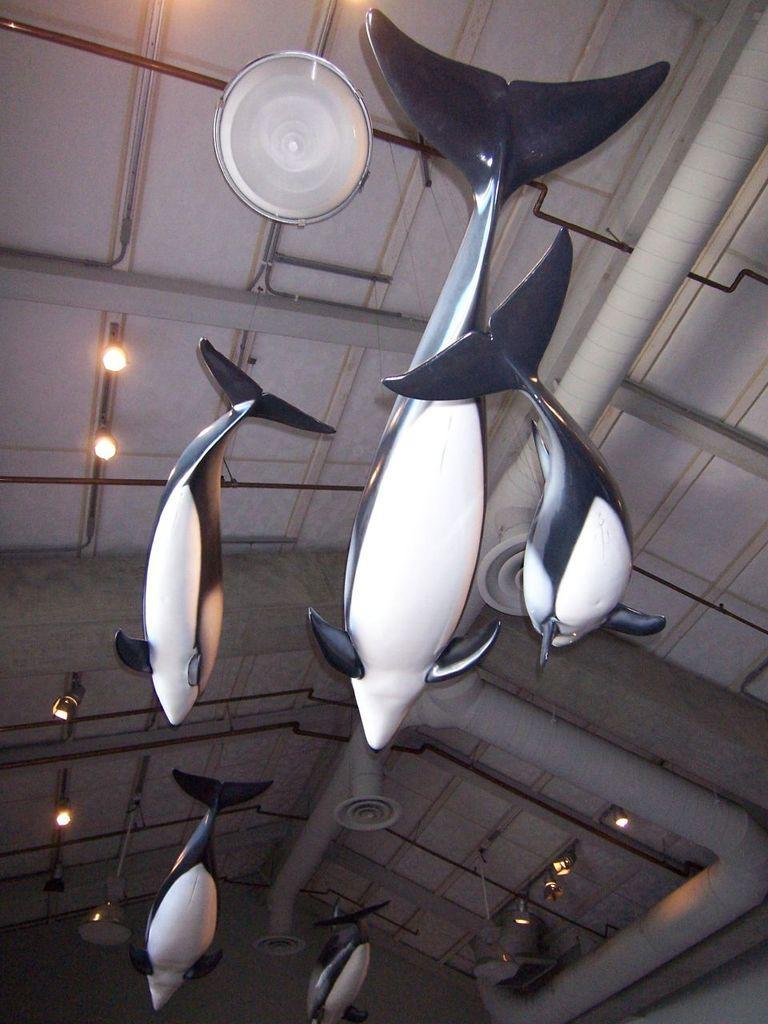How would you summarize this image in a sentence or two? In this image few fish toys are hanging from the roof having few lights attached to it. 